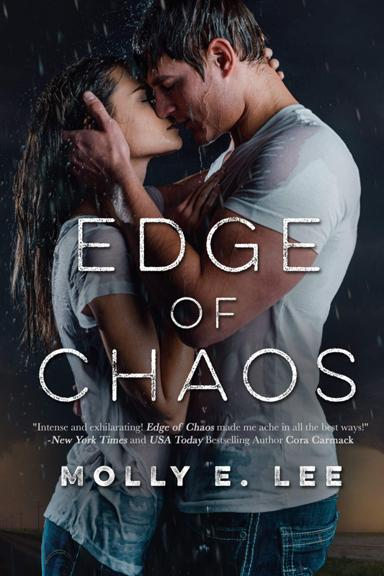Is this book part of a series or a standalone novel? The book 'Edge of Chaos' appears to be a standalone novel by Molly E. Lee. However, the author is known for writing other romance novels which might be worth exploring if you enjoy themes similar to those in 'Edge of Chaos.' Can you tell me about other books by the same author? Molly E. Lee is known for her engaging and dramatic romance novels. Some of her other popular works include the 'Love on the Edge' series, which is filled with adventure-driven romantic stories. 